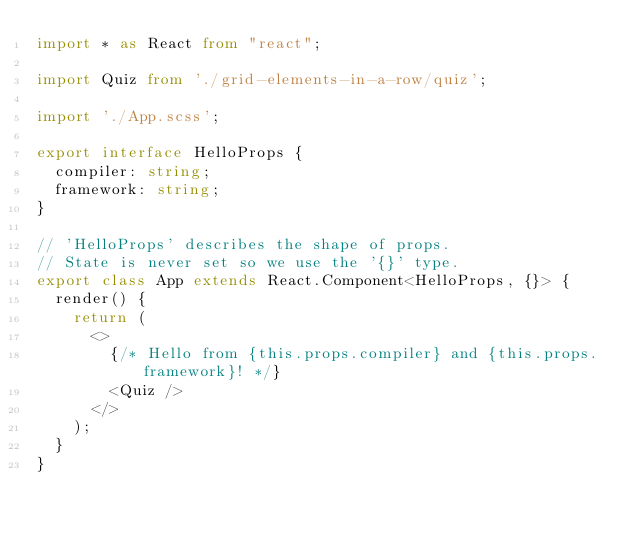Convert code to text. <code><loc_0><loc_0><loc_500><loc_500><_TypeScript_>import * as React from "react";

import Quiz from './grid-elements-in-a-row/quiz';

import './App.scss';

export interface HelloProps {
  compiler: string;
  framework: string;
}

// 'HelloProps' describes the shape of props.
// State is never set so we use the '{}' type.
export class App extends React.Component<HelloProps, {}> {
  render() {
    return (
      <>
        {/* Hello from {this.props.compiler} and {this.props.framework}! */}
        <Quiz />
      </>
    );
  }
}</code> 